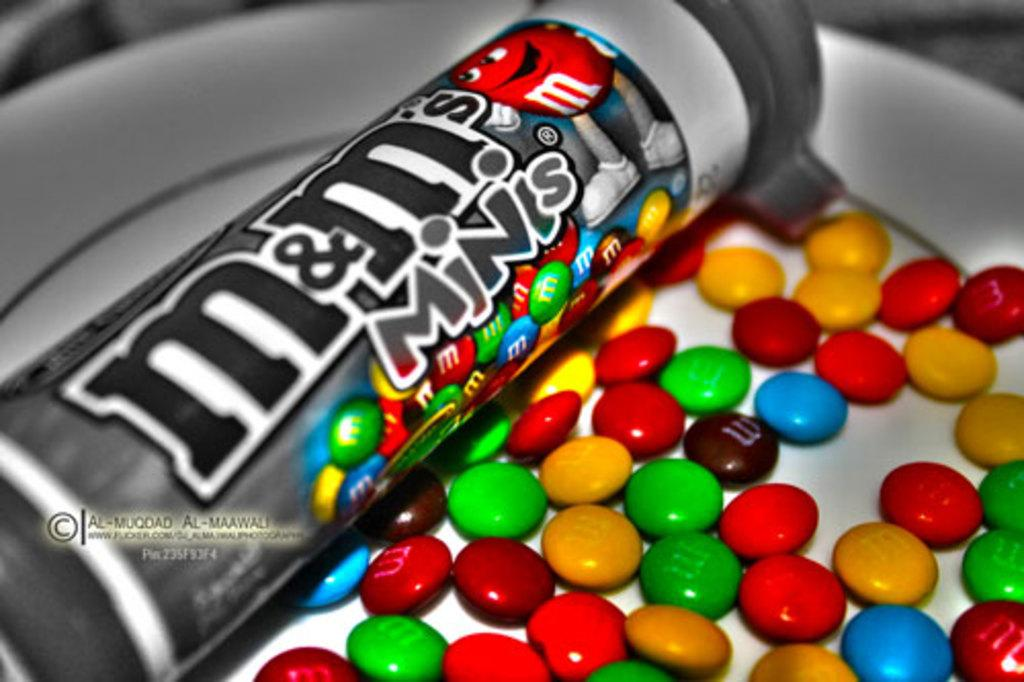What type of food is on the plate in the image? There are candies on a plate in the image. What else is on the plate besides the candies? There is a box on the plate in the image. What can be seen on the box? There is text on the box in the image. Where is the text located in the image? There is text on the left side of the image. What type of sound can be heard coming from the candies in the image? There is no sound coming from the candies in the image, as they are stationary and inanimate objects. 